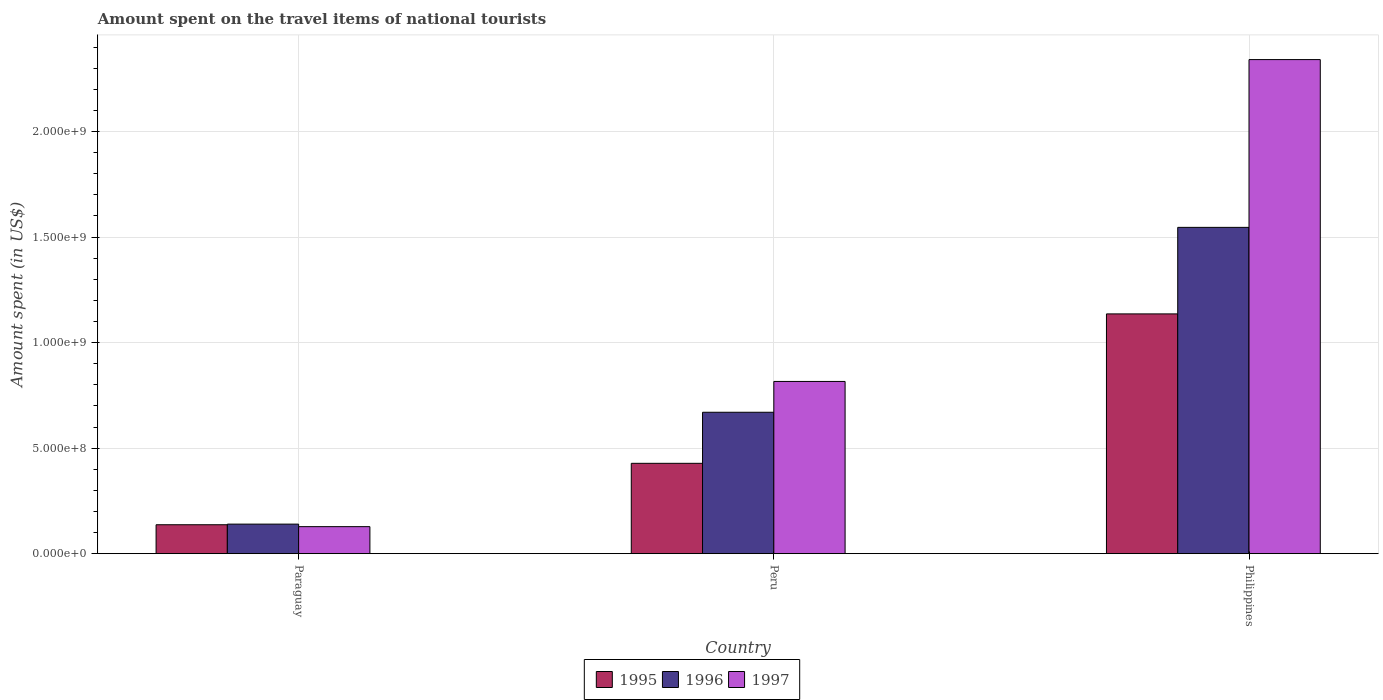Are the number of bars on each tick of the X-axis equal?
Keep it short and to the point. Yes. How many bars are there on the 1st tick from the left?
Your answer should be very brief. 3. How many bars are there on the 3rd tick from the right?
Offer a very short reply. 3. In how many cases, is the number of bars for a given country not equal to the number of legend labels?
Provide a short and direct response. 0. What is the amount spent on the travel items of national tourists in 1996 in Paraguay?
Provide a short and direct response. 1.40e+08. Across all countries, what is the maximum amount spent on the travel items of national tourists in 1996?
Your answer should be compact. 1.55e+09. Across all countries, what is the minimum amount spent on the travel items of national tourists in 1995?
Your answer should be very brief. 1.37e+08. In which country was the amount spent on the travel items of national tourists in 1997 minimum?
Ensure brevity in your answer.  Paraguay. What is the total amount spent on the travel items of national tourists in 1997 in the graph?
Provide a short and direct response. 3.28e+09. What is the difference between the amount spent on the travel items of national tourists in 1995 in Peru and that in Philippines?
Make the answer very short. -7.08e+08. What is the difference between the amount spent on the travel items of national tourists in 1997 in Peru and the amount spent on the travel items of national tourists in 1995 in Philippines?
Keep it short and to the point. -3.20e+08. What is the average amount spent on the travel items of national tourists in 1996 per country?
Keep it short and to the point. 7.85e+08. What is the difference between the amount spent on the travel items of national tourists of/in 1996 and amount spent on the travel items of national tourists of/in 1997 in Philippines?
Ensure brevity in your answer.  -7.95e+08. In how many countries, is the amount spent on the travel items of national tourists in 1997 greater than 900000000 US$?
Offer a very short reply. 1. What is the ratio of the amount spent on the travel items of national tourists in 1995 in Peru to that in Philippines?
Provide a short and direct response. 0.38. What is the difference between the highest and the second highest amount spent on the travel items of national tourists in 1997?
Your answer should be compact. 1.52e+09. What is the difference between the highest and the lowest amount spent on the travel items of national tourists in 1997?
Provide a succinct answer. 2.21e+09. Is the sum of the amount spent on the travel items of national tourists in 1995 in Peru and Philippines greater than the maximum amount spent on the travel items of national tourists in 1997 across all countries?
Provide a succinct answer. No. Is it the case that in every country, the sum of the amount spent on the travel items of national tourists in 1996 and amount spent on the travel items of national tourists in 1997 is greater than the amount spent on the travel items of national tourists in 1995?
Your answer should be compact. Yes. Are all the bars in the graph horizontal?
Make the answer very short. No. How many countries are there in the graph?
Your answer should be very brief. 3. What is the difference between two consecutive major ticks on the Y-axis?
Provide a short and direct response. 5.00e+08. Are the values on the major ticks of Y-axis written in scientific E-notation?
Make the answer very short. Yes. Does the graph contain grids?
Your answer should be compact. Yes. Where does the legend appear in the graph?
Provide a short and direct response. Bottom center. What is the title of the graph?
Keep it short and to the point. Amount spent on the travel items of national tourists. What is the label or title of the X-axis?
Your answer should be very brief. Country. What is the label or title of the Y-axis?
Your response must be concise. Amount spent (in US$). What is the Amount spent (in US$) in 1995 in Paraguay?
Provide a succinct answer. 1.37e+08. What is the Amount spent (in US$) of 1996 in Paraguay?
Your answer should be very brief. 1.40e+08. What is the Amount spent (in US$) of 1997 in Paraguay?
Your answer should be compact. 1.28e+08. What is the Amount spent (in US$) of 1995 in Peru?
Make the answer very short. 4.28e+08. What is the Amount spent (in US$) of 1996 in Peru?
Provide a short and direct response. 6.70e+08. What is the Amount spent (in US$) in 1997 in Peru?
Give a very brief answer. 8.16e+08. What is the Amount spent (in US$) of 1995 in Philippines?
Your response must be concise. 1.14e+09. What is the Amount spent (in US$) of 1996 in Philippines?
Give a very brief answer. 1.55e+09. What is the Amount spent (in US$) of 1997 in Philippines?
Your answer should be compact. 2.34e+09. Across all countries, what is the maximum Amount spent (in US$) in 1995?
Your answer should be compact. 1.14e+09. Across all countries, what is the maximum Amount spent (in US$) of 1996?
Offer a terse response. 1.55e+09. Across all countries, what is the maximum Amount spent (in US$) in 1997?
Offer a very short reply. 2.34e+09. Across all countries, what is the minimum Amount spent (in US$) of 1995?
Provide a short and direct response. 1.37e+08. Across all countries, what is the minimum Amount spent (in US$) of 1996?
Your response must be concise. 1.40e+08. Across all countries, what is the minimum Amount spent (in US$) in 1997?
Make the answer very short. 1.28e+08. What is the total Amount spent (in US$) of 1995 in the graph?
Your response must be concise. 1.70e+09. What is the total Amount spent (in US$) in 1996 in the graph?
Offer a terse response. 2.36e+09. What is the total Amount spent (in US$) in 1997 in the graph?
Ensure brevity in your answer.  3.28e+09. What is the difference between the Amount spent (in US$) in 1995 in Paraguay and that in Peru?
Your answer should be very brief. -2.91e+08. What is the difference between the Amount spent (in US$) in 1996 in Paraguay and that in Peru?
Offer a terse response. -5.30e+08. What is the difference between the Amount spent (in US$) in 1997 in Paraguay and that in Peru?
Give a very brief answer. -6.88e+08. What is the difference between the Amount spent (in US$) in 1995 in Paraguay and that in Philippines?
Provide a succinct answer. -9.99e+08. What is the difference between the Amount spent (in US$) in 1996 in Paraguay and that in Philippines?
Your answer should be very brief. -1.41e+09. What is the difference between the Amount spent (in US$) of 1997 in Paraguay and that in Philippines?
Provide a short and direct response. -2.21e+09. What is the difference between the Amount spent (in US$) in 1995 in Peru and that in Philippines?
Ensure brevity in your answer.  -7.08e+08. What is the difference between the Amount spent (in US$) in 1996 in Peru and that in Philippines?
Your answer should be compact. -8.76e+08. What is the difference between the Amount spent (in US$) in 1997 in Peru and that in Philippines?
Provide a short and direct response. -1.52e+09. What is the difference between the Amount spent (in US$) in 1995 in Paraguay and the Amount spent (in US$) in 1996 in Peru?
Your answer should be very brief. -5.33e+08. What is the difference between the Amount spent (in US$) of 1995 in Paraguay and the Amount spent (in US$) of 1997 in Peru?
Keep it short and to the point. -6.79e+08. What is the difference between the Amount spent (in US$) in 1996 in Paraguay and the Amount spent (in US$) in 1997 in Peru?
Offer a very short reply. -6.76e+08. What is the difference between the Amount spent (in US$) in 1995 in Paraguay and the Amount spent (in US$) in 1996 in Philippines?
Offer a very short reply. -1.41e+09. What is the difference between the Amount spent (in US$) of 1995 in Paraguay and the Amount spent (in US$) of 1997 in Philippines?
Provide a short and direct response. -2.20e+09. What is the difference between the Amount spent (in US$) in 1996 in Paraguay and the Amount spent (in US$) in 1997 in Philippines?
Your answer should be very brief. -2.20e+09. What is the difference between the Amount spent (in US$) of 1995 in Peru and the Amount spent (in US$) of 1996 in Philippines?
Your answer should be very brief. -1.12e+09. What is the difference between the Amount spent (in US$) in 1995 in Peru and the Amount spent (in US$) in 1997 in Philippines?
Your answer should be compact. -1.91e+09. What is the difference between the Amount spent (in US$) of 1996 in Peru and the Amount spent (in US$) of 1997 in Philippines?
Offer a very short reply. -1.67e+09. What is the average Amount spent (in US$) of 1995 per country?
Keep it short and to the point. 5.67e+08. What is the average Amount spent (in US$) of 1996 per country?
Offer a very short reply. 7.85e+08. What is the average Amount spent (in US$) of 1997 per country?
Your response must be concise. 1.10e+09. What is the difference between the Amount spent (in US$) in 1995 and Amount spent (in US$) in 1996 in Paraguay?
Keep it short and to the point. -3.00e+06. What is the difference between the Amount spent (in US$) in 1995 and Amount spent (in US$) in 1997 in Paraguay?
Offer a terse response. 9.00e+06. What is the difference between the Amount spent (in US$) in 1995 and Amount spent (in US$) in 1996 in Peru?
Your answer should be compact. -2.42e+08. What is the difference between the Amount spent (in US$) of 1995 and Amount spent (in US$) of 1997 in Peru?
Your answer should be compact. -3.88e+08. What is the difference between the Amount spent (in US$) of 1996 and Amount spent (in US$) of 1997 in Peru?
Give a very brief answer. -1.46e+08. What is the difference between the Amount spent (in US$) in 1995 and Amount spent (in US$) in 1996 in Philippines?
Offer a terse response. -4.10e+08. What is the difference between the Amount spent (in US$) in 1995 and Amount spent (in US$) in 1997 in Philippines?
Provide a short and direct response. -1.20e+09. What is the difference between the Amount spent (in US$) of 1996 and Amount spent (in US$) of 1997 in Philippines?
Provide a short and direct response. -7.95e+08. What is the ratio of the Amount spent (in US$) of 1995 in Paraguay to that in Peru?
Give a very brief answer. 0.32. What is the ratio of the Amount spent (in US$) in 1996 in Paraguay to that in Peru?
Make the answer very short. 0.21. What is the ratio of the Amount spent (in US$) in 1997 in Paraguay to that in Peru?
Your answer should be compact. 0.16. What is the ratio of the Amount spent (in US$) in 1995 in Paraguay to that in Philippines?
Provide a succinct answer. 0.12. What is the ratio of the Amount spent (in US$) of 1996 in Paraguay to that in Philippines?
Your answer should be very brief. 0.09. What is the ratio of the Amount spent (in US$) in 1997 in Paraguay to that in Philippines?
Offer a very short reply. 0.05. What is the ratio of the Amount spent (in US$) in 1995 in Peru to that in Philippines?
Provide a short and direct response. 0.38. What is the ratio of the Amount spent (in US$) of 1996 in Peru to that in Philippines?
Make the answer very short. 0.43. What is the ratio of the Amount spent (in US$) in 1997 in Peru to that in Philippines?
Your response must be concise. 0.35. What is the difference between the highest and the second highest Amount spent (in US$) of 1995?
Your answer should be very brief. 7.08e+08. What is the difference between the highest and the second highest Amount spent (in US$) of 1996?
Keep it short and to the point. 8.76e+08. What is the difference between the highest and the second highest Amount spent (in US$) in 1997?
Your response must be concise. 1.52e+09. What is the difference between the highest and the lowest Amount spent (in US$) of 1995?
Give a very brief answer. 9.99e+08. What is the difference between the highest and the lowest Amount spent (in US$) of 1996?
Offer a terse response. 1.41e+09. What is the difference between the highest and the lowest Amount spent (in US$) of 1997?
Offer a terse response. 2.21e+09. 